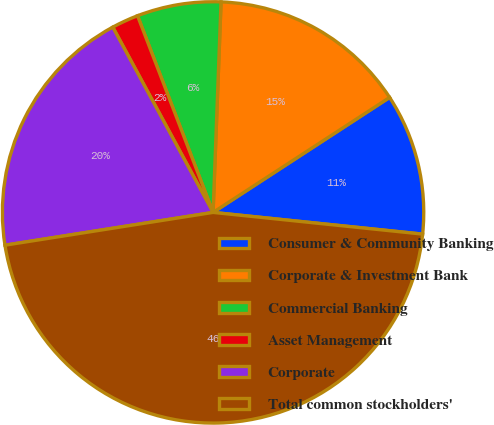Convert chart. <chart><loc_0><loc_0><loc_500><loc_500><pie_chart><fcel>Consumer & Community Banking<fcel>Corporate & Investment Bank<fcel>Commercial Banking<fcel>Asset Management<fcel>Corporate<fcel>Total common stockholders'<nl><fcel>10.83%<fcel>15.21%<fcel>6.44%<fcel>2.06%<fcel>19.59%<fcel>45.87%<nl></chart> 